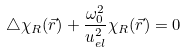Convert formula to latex. <formula><loc_0><loc_0><loc_500><loc_500>\triangle \chi _ { R } ( \vec { r } ) + \frac { \omega _ { 0 } ^ { 2 } } { u _ { e l } ^ { 2 } } \chi _ { R } ( \vec { r } ) = 0</formula> 